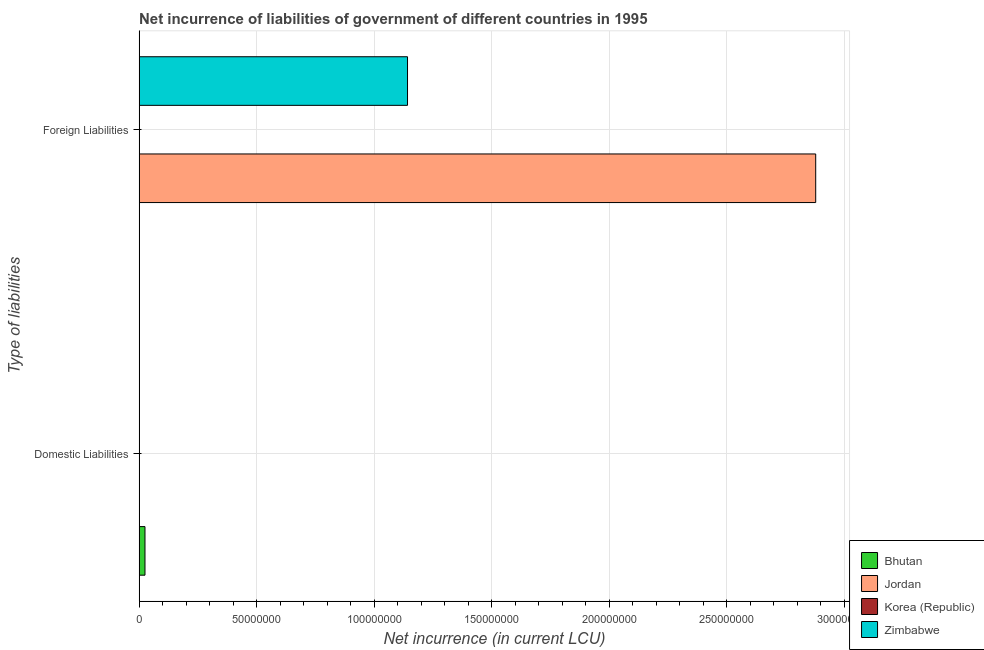How many different coloured bars are there?
Ensure brevity in your answer.  3. Are the number of bars on each tick of the Y-axis equal?
Provide a succinct answer. No. How many bars are there on the 2nd tick from the top?
Make the answer very short. 1. How many bars are there on the 2nd tick from the bottom?
Make the answer very short. 2. What is the label of the 2nd group of bars from the top?
Your answer should be very brief. Domestic Liabilities. What is the net incurrence of foreign liabilities in Jordan?
Ensure brevity in your answer.  2.88e+08. Across all countries, what is the maximum net incurrence of domestic liabilities?
Provide a short and direct response. 2.50e+06. In which country was the net incurrence of domestic liabilities maximum?
Provide a succinct answer. Bhutan. What is the total net incurrence of foreign liabilities in the graph?
Provide a succinct answer. 4.02e+08. What is the average net incurrence of domestic liabilities per country?
Offer a very short reply. 6.25e+05. What is the ratio of the net incurrence of foreign liabilities in Zimbabwe to that in Jordan?
Provide a short and direct response. 0.4. In how many countries, is the net incurrence of foreign liabilities greater than the average net incurrence of foreign liabilities taken over all countries?
Your response must be concise. 2. How many bars are there?
Provide a short and direct response. 3. Are all the bars in the graph horizontal?
Keep it short and to the point. Yes. Are the values on the major ticks of X-axis written in scientific E-notation?
Give a very brief answer. No. Does the graph contain grids?
Give a very brief answer. Yes. Where does the legend appear in the graph?
Make the answer very short. Bottom right. How many legend labels are there?
Provide a short and direct response. 4. What is the title of the graph?
Offer a terse response. Net incurrence of liabilities of government of different countries in 1995. Does "Bolivia" appear as one of the legend labels in the graph?
Keep it short and to the point. No. What is the label or title of the X-axis?
Offer a very short reply. Net incurrence (in current LCU). What is the label or title of the Y-axis?
Provide a succinct answer. Type of liabilities. What is the Net incurrence (in current LCU) in Bhutan in Domestic Liabilities?
Your answer should be very brief. 2.50e+06. What is the Net incurrence (in current LCU) in Bhutan in Foreign Liabilities?
Make the answer very short. 0. What is the Net incurrence (in current LCU) of Jordan in Foreign Liabilities?
Provide a succinct answer. 2.88e+08. What is the Net incurrence (in current LCU) of Zimbabwe in Foreign Liabilities?
Provide a short and direct response. 1.14e+08. Across all Type of liabilities, what is the maximum Net incurrence (in current LCU) in Bhutan?
Keep it short and to the point. 2.50e+06. Across all Type of liabilities, what is the maximum Net incurrence (in current LCU) in Jordan?
Offer a very short reply. 2.88e+08. Across all Type of liabilities, what is the maximum Net incurrence (in current LCU) in Zimbabwe?
Keep it short and to the point. 1.14e+08. Across all Type of liabilities, what is the minimum Net incurrence (in current LCU) in Bhutan?
Provide a short and direct response. 0. Across all Type of liabilities, what is the minimum Net incurrence (in current LCU) in Jordan?
Provide a short and direct response. 0. What is the total Net incurrence (in current LCU) in Bhutan in the graph?
Give a very brief answer. 2.50e+06. What is the total Net incurrence (in current LCU) in Jordan in the graph?
Keep it short and to the point. 2.88e+08. What is the total Net incurrence (in current LCU) of Zimbabwe in the graph?
Your answer should be very brief. 1.14e+08. What is the difference between the Net incurrence (in current LCU) in Bhutan in Domestic Liabilities and the Net incurrence (in current LCU) in Jordan in Foreign Liabilities?
Ensure brevity in your answer.  -2.85e+08. What is the difference between the Net incurrence (in current LCU) in Bhutan in Domestic Liabilities and the Net incurrence (in current LCU) in Zimbabwe in Foreign Liabilities?
Your answer should be compact. -1.12e+08. What is the average Net incurrence (in current LCU) in Bhutan per Type of liabilities?
Provide a short and direct response. 1.25e+06. What is the average Net incurrence (in current LCU) in Jordan per Type of liabilities?
Offer a terse response. 1.44e+08. What is the average Net incurrence (in current LCU) in Zimbabwe per Type of liabilities?
Your answer should be very brief. 5.71e+07. What is the difference between the Net incurrence (in current LCU) in Jordan and Net incurrence (in current LCU) in Zimbabwe in Foreign Liabilities?
Your response must be concise. 1.74e+08. What is the difference between the highest and the lowest Net incurrence (in current LCU) in Bhutan?
Your response must be concise. 2.50e+06. What is the difference between the highest and the lowest Net incurrence (in current LCU) in Jordan?
Your response must be concise. 2.88e+08. What is the difference between the highest and the lowest Net incurrence (in current LCU) of Zimbabwe?
Your answer should be compact. 1.14e+08. 